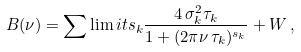Convert formula to latex. <formula><loc_0><loc_0><loc_500><loc_500>B ( \nu ) = \sum \lim i t s _ { k } \frac { 4 \, \sigma _ { k } ^ { 2 } \tau _ { k } } { 1 + ( 2 \pi \nu \, \tau _ { k } ) ^ { s _ { k } } } + W \, ,</formula> 